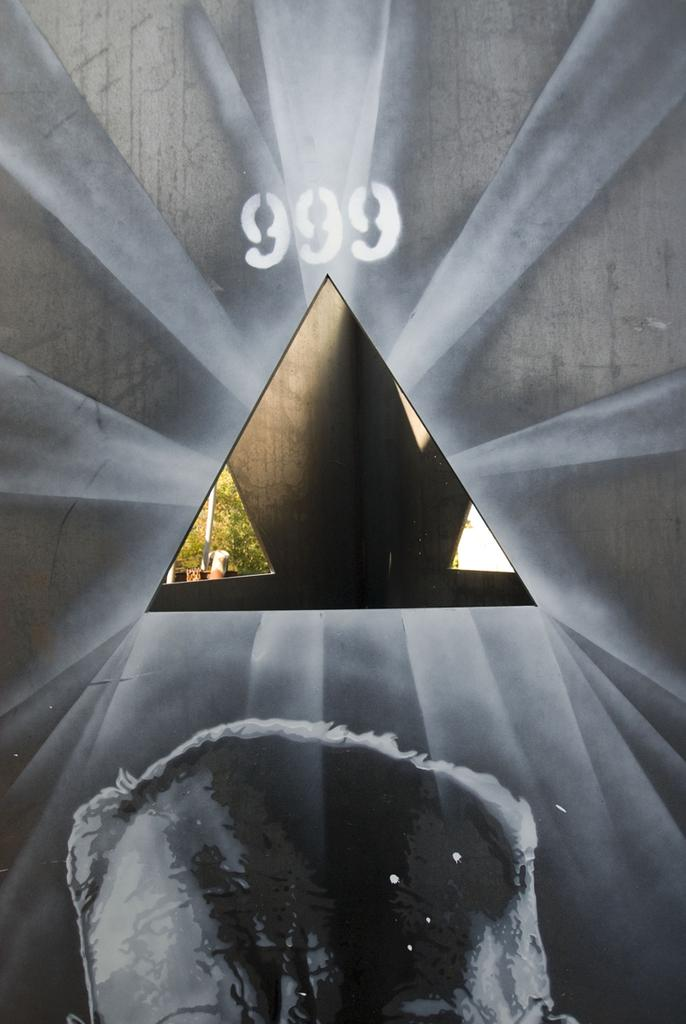What is the main subject of the image? There is a painting in the image. What else can be seen on the wall in the image? There is a number on the wall in the image. What type of natural scenery is visible in the image? There are trees visible in the image. What object can be seen standing upright in the image? There is a pole in the image. Can you describe the person in the image? There is a person in the image, but they are truncated towards the bottom. What type of pump can be seen in the image? There is no pump present in the image. What color is the chalk used to write on the wall in the image? There is no chalk or writing on the wall in the image. 